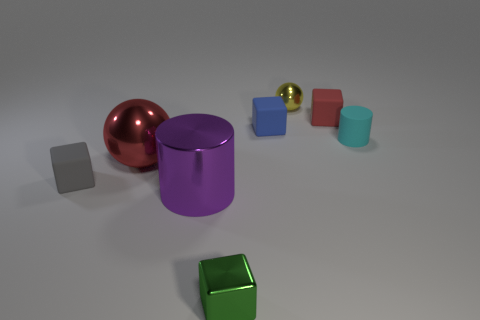What is the shape of the blue thing that is the same size as the cyan matte cylinder?
Provide a short and direct response. Cube. Is there a tiny cyan thing of the same shape as the purple shiny object?
Your answer should be compact. Yes. Are there fewer gray matte blocks than small brown spheres?
Your answer should be very brief. No. Does the ball that is right of the big red metal ball have the same size as the red thing in front of the tiny blue rubber block?
Ensure brevity in your answer.  No. What number of objects are either blue matte blocks or big matte cubes?
Your answer should be compact. 1. There is a ball that is behind the red matte object; what size is it?
Give a very brief answer. Small. How many matte blocks are behind the large metallic object behind the small matte block in front of the cyan matte cylinder?
Make the answer very short. 2. How many matte things are both behind the small cyan matte cylinder and in front of the large ball?
Offer a terse response. 0. What shape is the large metallic object that is to the left of the purple cylinder?
Your response must be concise. Sphere. Is the number of cylinders that are in front of the green cube less than the number of small yellow things to the left of the tiny red rubber object?
Give a very brief answer. Yes. 